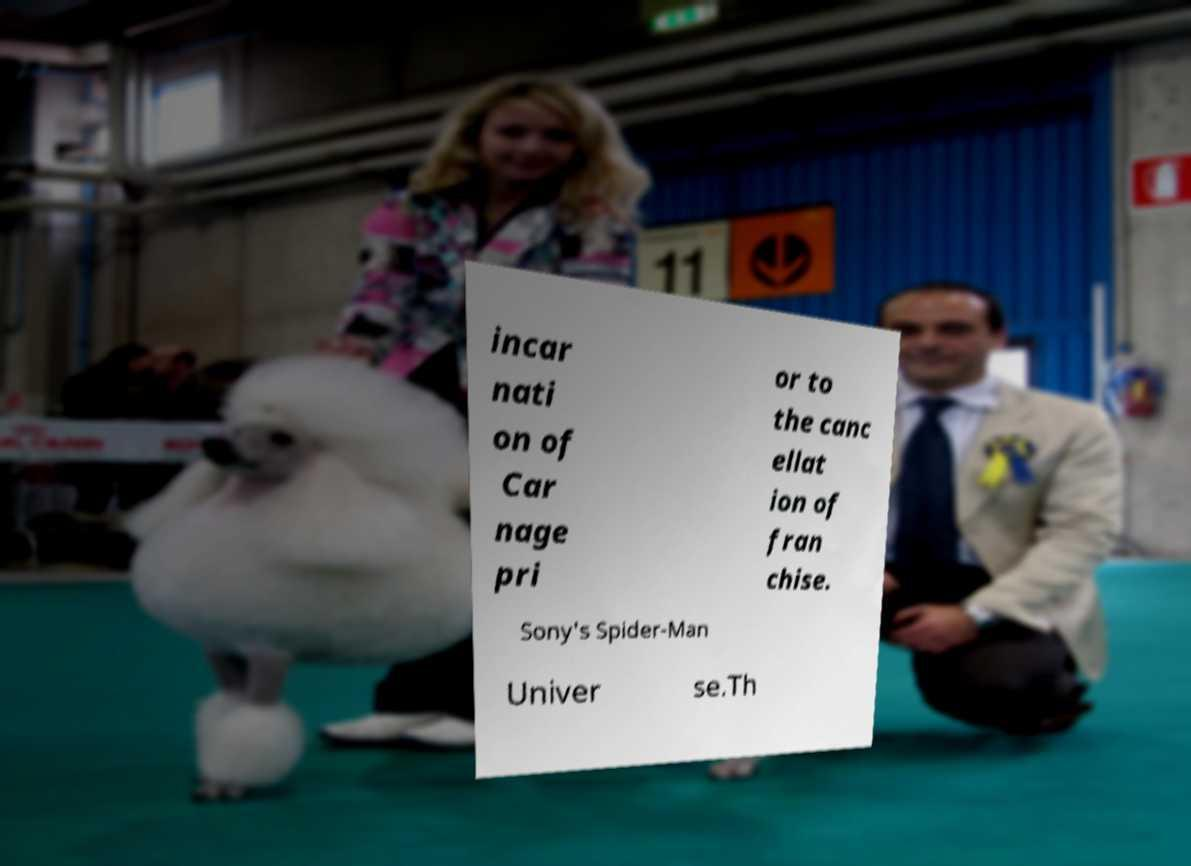Can you accurately transcribe the text from the provided image for me? incar nati on of Car nage pri or to the canc ellat ion of fran chise. Sony's Spider-Man Univer se.Th 